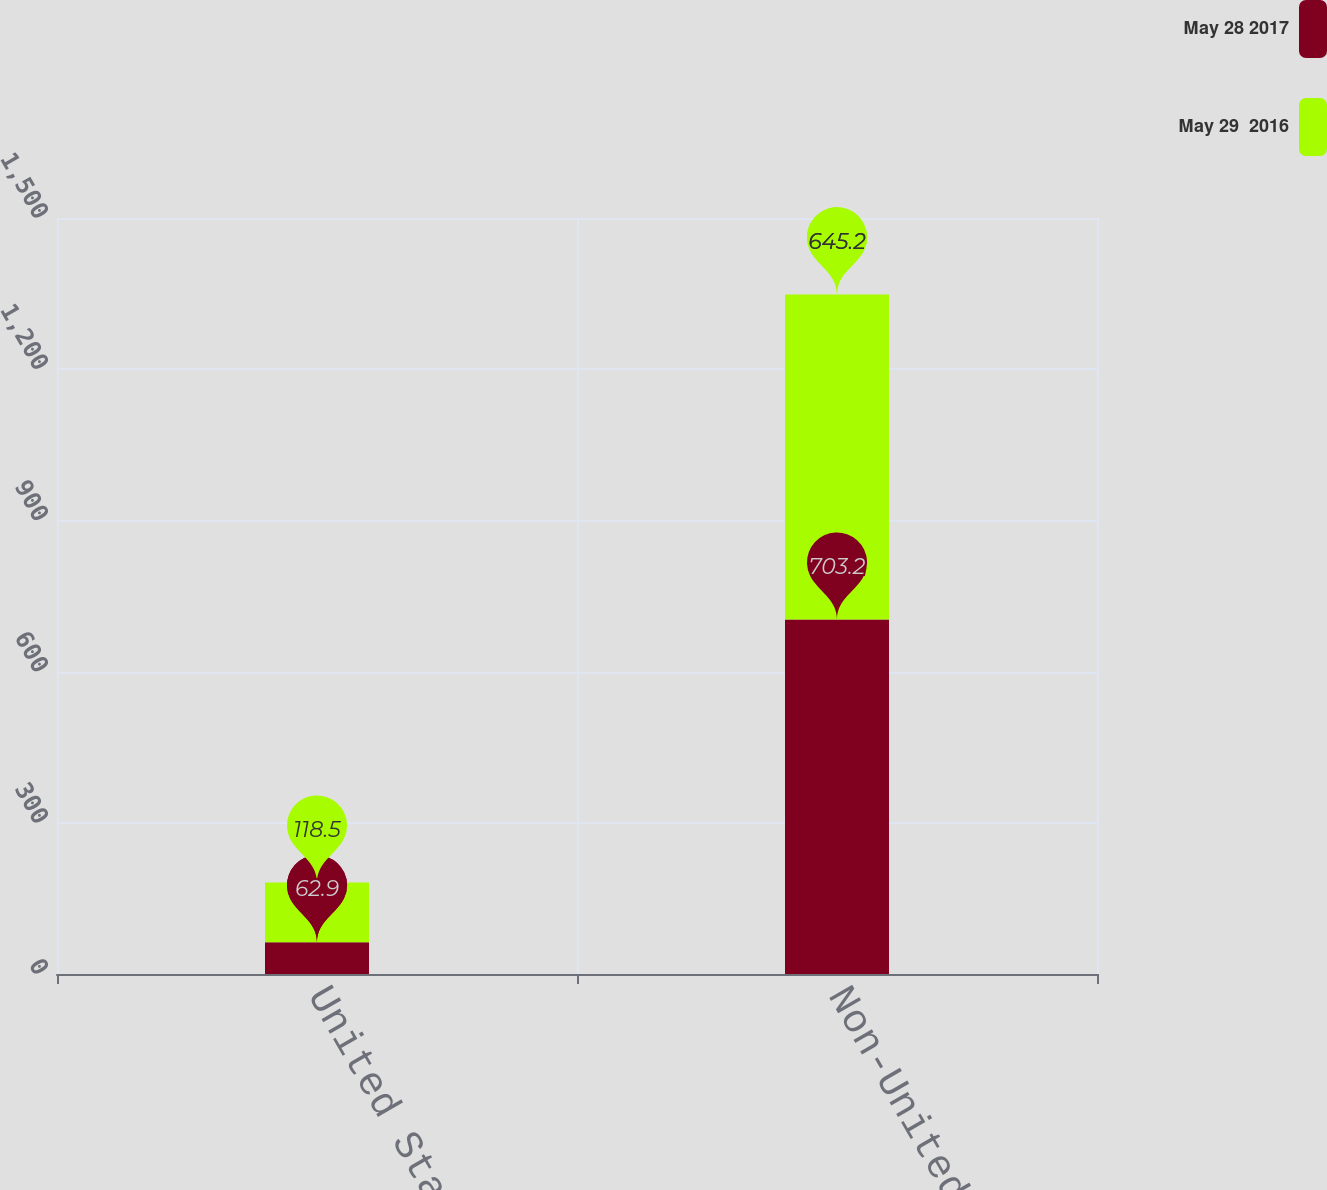Convert chart to OTSL. <chart><loc_0><loc_0><loc_500><loc_500><stacked_bar_chart><ecel><fcel>United States<fcel>Non-United States<nl><fcel>May 28 2017<fcel>62.9<fcel>703.2<nl><fcel>May 29  2016<fcel>118.5<fcel>645.2<nl></chart> 